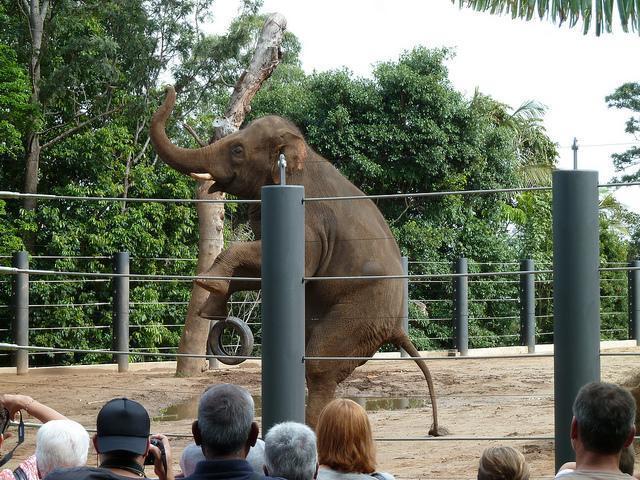How many people are there?
Give a very brief answer. 6. How many motorcycles are on the road?
Give a very brief answer. 0. 